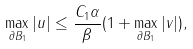Convert formula to latex. <formula><loc_0><loc_0><loc_500><loc_500>\max _ { \partial B _ { 1 } } | u | \leq \frac { C _ { 1 } \alpha } { \beta } ( 1 + \max _ { \partial B _ { 1 } } | v | ) ,</formula> 